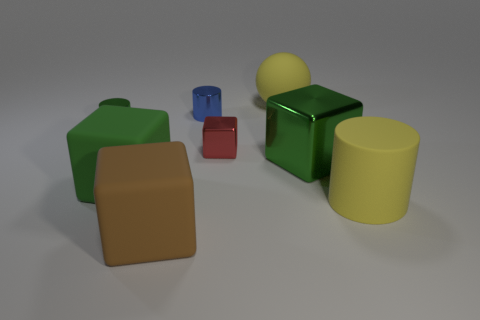Subtract all tiny red cubes. How many cubes are left? 3 Subtract all green cylinders. How many green blocks are left? 2 Subtract all red blocks. How many blocks are left? 3 Add 2 small blue cylinders. How many objects exist? 10 Subtract 2 blocks. How many blocks are left? 2 Subtract all spheres. How many objects are left? 7 Add 3 tiny metallic cylinders. How many tiny metallic cylinders are left? 5 Add 8 large brown matte objects. How many large brown matte objects exist? 9 Subtract 1 brown blocks. How many objects are left? 7 Subtract all purple blocks. Subtract all purple cylinders. How many blocks are left? 4 